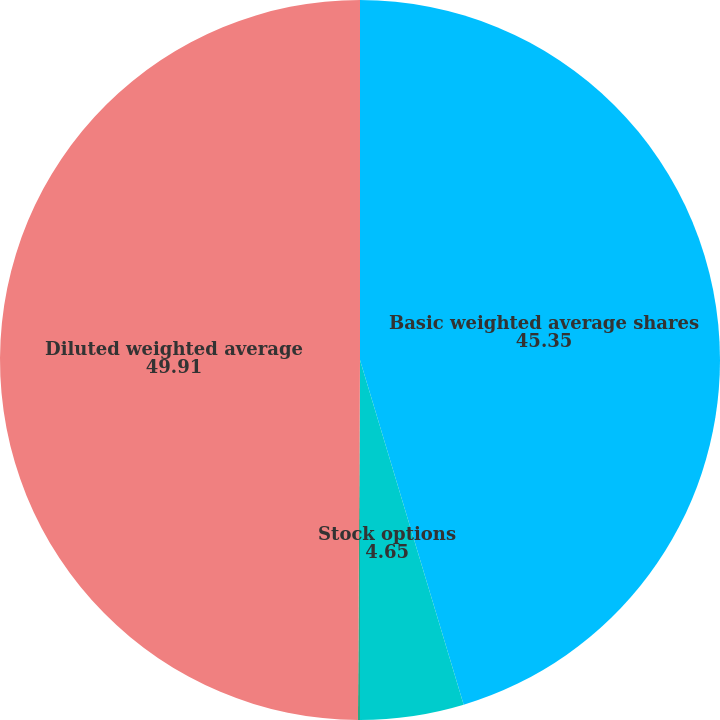<chart> <loc_0><loc_0><loc_500><loc_500><pie_chart><fcel>Basic weighted average shares<fcel>Stock options<fcel>Restricted stock units<fcel>Diluted weighted average<nl><fcel>45.35%<fcel>4.65%<fcel>0.09%<fcel>49.91%<nl></chart> 